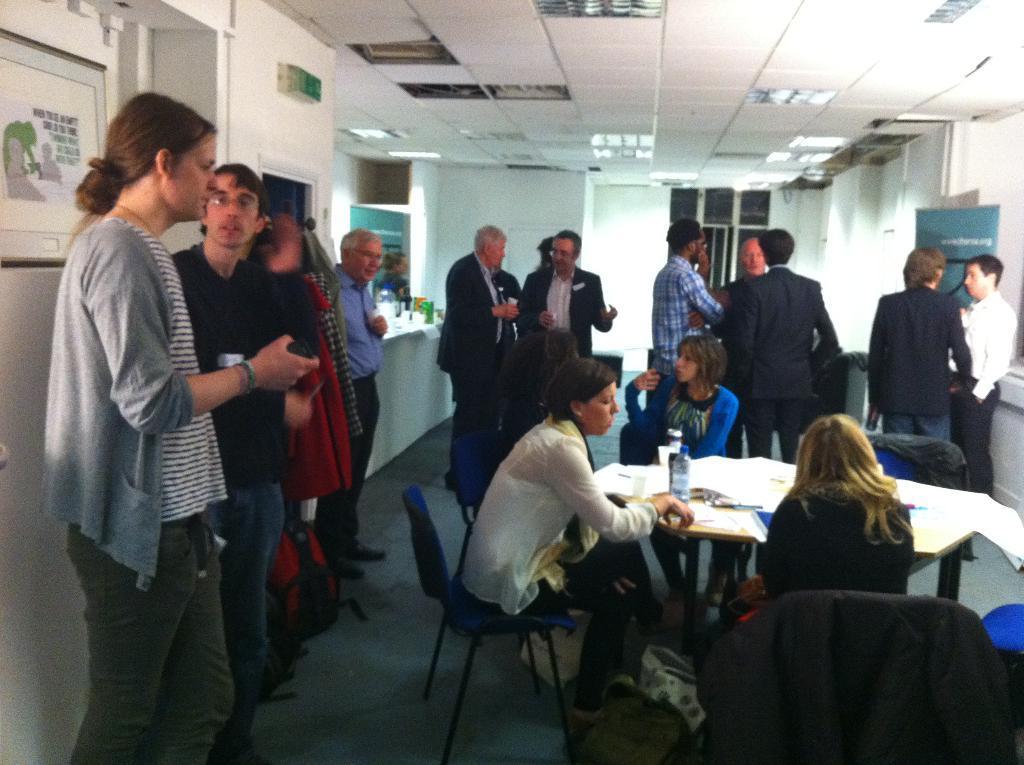How would you summarize this image in a sentence or two? In this image we can see the people standing on the floor. We can also see three women sitting on the chairs in front of the table and on the table we can see the bottle and some other objects. We can see the frame attached to the wall. We can also see the banners, board, door and also the ceiling with the lights. 